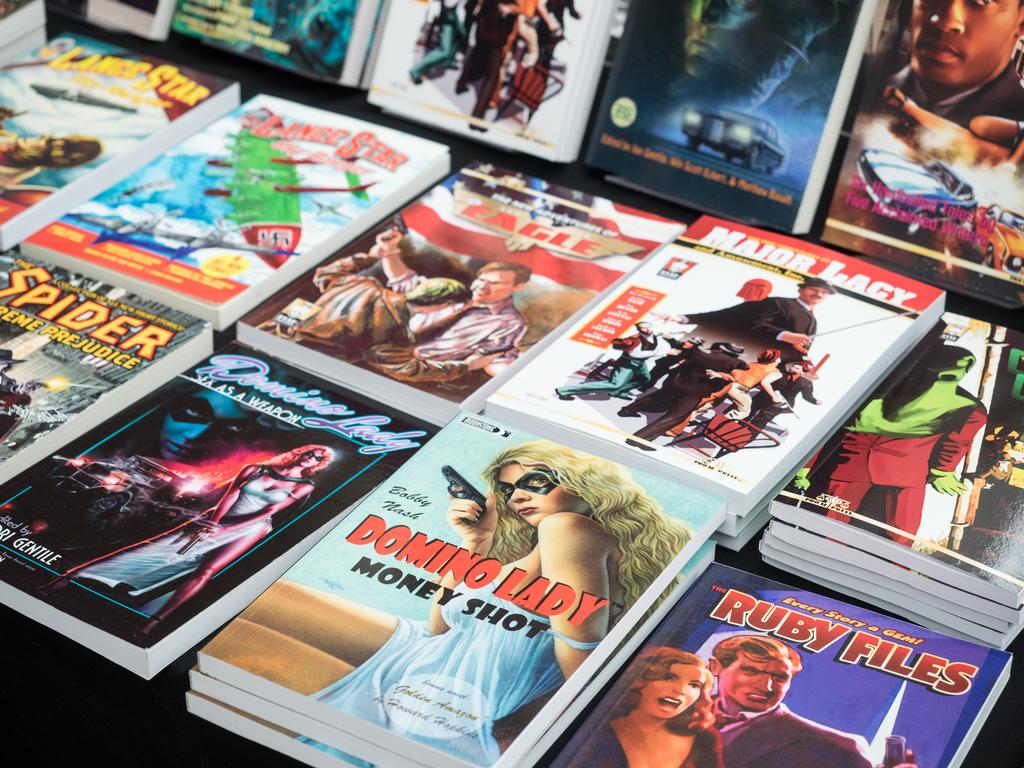<image>
Give a short and clear explanation of the subsequent image. Various graphic comics, including Domino Lady, are stacked up display. 